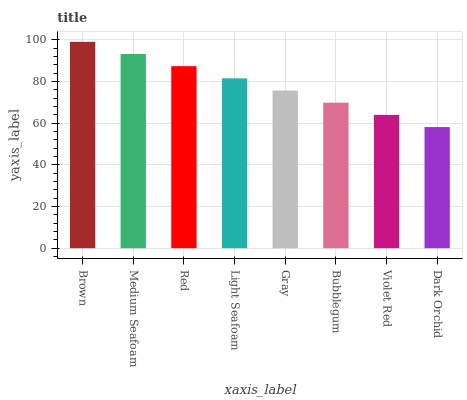Is Dark Orchid the minimum?
Answer yes or no. Yes. Is Brown the maximum?
Answer yes or no. Yes. Is Medium Seafoam the minimum?
Answer yes or no. No. Is Medium Seafoam the maximum?
Answer yes or no. No. Is Brown greater than Medium Seafoam?
Answer yes or no. Yes. Is Medium Seafoam less than Brown?
Answer yes or no. Yes. Is Medium Seafoam greater than Brown?
Answer yes or no. No. Is Brown less than Medium Seafoam?
Answer yes or no. No. Is Light Seafoam the high median?
Answer yes or no. Yes. Is Gray the low median?
Answer yes or no. Yes. Is Medium Seafoam the high median?
Answer yes or no. No. Is Bubblegum the low median?
Answer yes or no. No. 